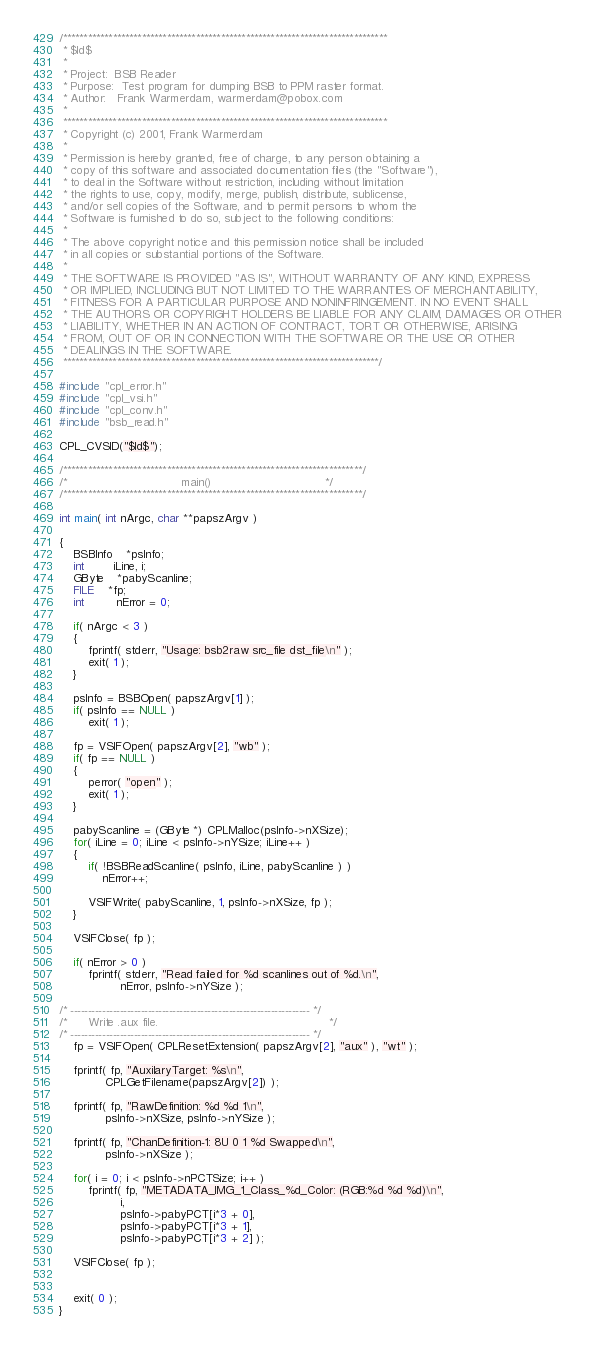Convert code to text. <code><loc_0><loc_0><loc_500><loc_500><_C_>/******************************************************************************
 * $Id$
 *
 * Project:  BSB Reader
 * Purpose:  Test program for dumping BSB to PPM raster format.
 * Author:   Frank Warmerdam, warmerdam@pobox.com
 *
 ******************************************************************************
 * Copyright (c) 2001, Frank Warmerdam
 *
 * Permission is hereby granted, free of charge, to any person obtaining a
 * copy of this software and associated documentation files (the "Software"),
 * to deal in the Software without restriction, including without limitation
 * the rights to use, copy, modify, merge, publish, distribute, sublicense,
 * and/or sell copies of the Software, and to permit persons to whom the
 * Software is furnished to do so, subject to the following conditions:
 *
 * The above copyright notice and this permission notice shall be included
 * in all copies or substantial portions of the Software.
 *
 * THE SOFTWARE IS PROVIDED "AS IS", WITHOUT WARRANTY OF ANY KIND, EXPRESS
 * OR IMPLIED, INCLUDING BUT NOT LIMITED TO THE WARRANTIES OF MERCHANTABILITY,
 * FITNESS FOR A PARTICULAR PURPOSE AND NONINFRINGEMENT. IN NO EVENT SHALL
 * THE AUTHORS OR COPYRIGHT HOLDERS BE LIABLE FOR ANY CLAIM, DAMAGES OR OTHER
 * LIABILITY, WHETHER IN AN ACTION OF CONTRACT, TORT OR OTHERWISE, ARISING
 * FROM, OUT OF OR IN CONNECTION WITH THE SOFTWARE OR THE USE OR OTHER
 * DEALINGS IN THE SOFTWARE.
 ****************************************************************************/

#include "cpl_error.h"
#include "cpl_vsi.h"
#include "cpl_conv.h"
#include "bsb_read.h"

CPL_CVSID("$Id$");

/************************************************************************/
/*                                main()                                */
/************************************************************************/

int main( int nArgc, char **papszArgv )

{
    BSBInfo	*psInfo;
    int		iLine, i;
    GByte	*pabyScanline;
    FILE	*fp;
    int         nError = 0;
    
    if( nArgc < 3 )
    {
        fprintf( stderr, "Usage: bsb2raw src_file dst_file\n" );
        exit( 1 );
    }

    psInfo = BSBOpen( papszArgv[1] );
    if( psInfo == NULL )
        exit( 1 );

    fp = VSIFOpen( papszArgv[2], "wb" );
    if( fp == NULL )
    {
        perror( "open" );
        exit( 1 );
    }
    
    pabyScanline = (GByte *) CPLMalloc(psInfo->nXSize);
    for( iLine = 0; iLine < psInfo->nYSize; iLine++ )
    {
        if( !BSBReadScanline( psInfo, iLine, pabyScanline ) )
            nError++;

        VSIFWrite( pabyScanline, 1, psInfo->nXSize, fp );
    }

    VSIFClose( fp );

    if( nError > 0 )
        fprintf( stderr, "Read failed for %d scanlines out of %d.\n",
                 nError, psInfo->nYSize );

/* -------------------------------------------------------------------- */
/*      Write .aux file.                                                */
/* -------------------------------------------------------------------- */
    fp = VSIFOpen( CPLResetExtension( papszArgv[2], "aux" ), "wt" );

    fprintf( fp, "AuxilaryTarget: %s\n", 
             CPLGetFilename(papszArgv[2]) );

    fprintf( fp, "RawDefinition: %d %d 1\n", 
             psInfo->nXSize, psInfo->nYSize );

    fprintf( fp, "ChanDefinition-1: 8U 0 1 %d Swapped\n", 
             psInfo->nXSize );

    for( i = 0; i < psInfo->nPCTSize; i++ )
        fprintf( fp, "METADATA_IMG_1_Class_%d_Color: (RGB:%d %d %d)\n",
                 i, 
                 psInfo->pabyPCT[i*3 + 0],
                 psInfo->pabyPCT[i*3 + 1],
                 psInfo->pabyPCT[i*3 + 2] );
    
    VSIFClose( fp );
    

    exit( 0 );
}


</code> 